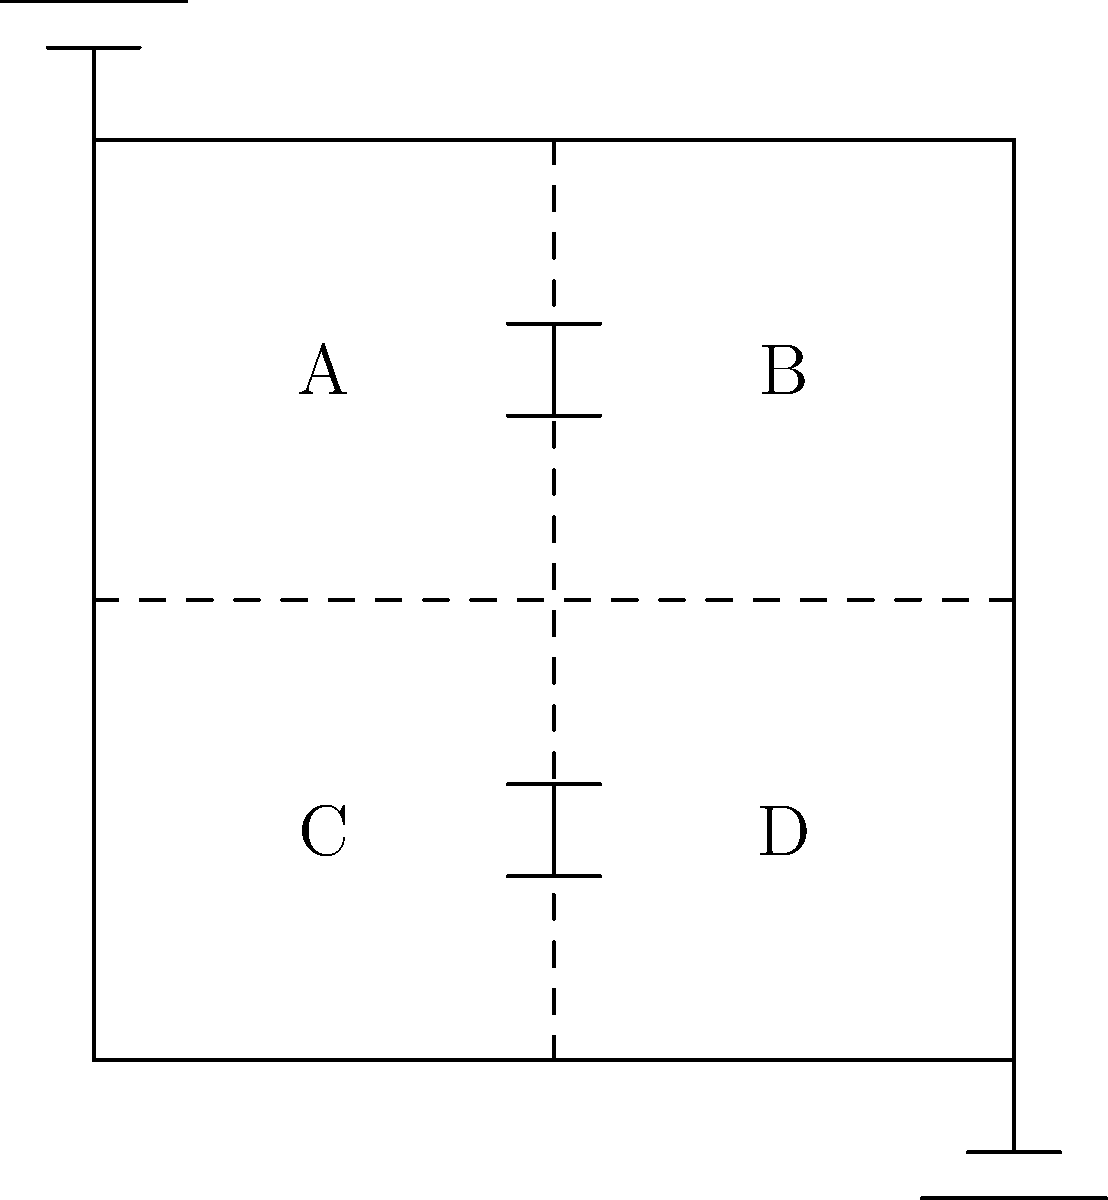In the given circuit diagram, which area(s) would require the highest level of plastic insulation to ensure optimal performance and safety, considering current market trends and regulations in the electrical insulation industry? To determine the optimal placement of plastic insulation in this electrical system, we need to consider several factors:

1. Voltage distribution: In a typical circuit, the highest voltage difference is usually between the power source and ground. This suggests that areas A and B would require more insulation than C and D.

2. Component sensitivity: Capacitors (shown in the middle of the circuit) are often more sensitive to electrical breakdown than resistors. This indicates that the areas around the capacitors might need extra insulation.

3. Current market trends: Recent trends in the plastic insulation market have focused on developing materials with higher dielectric strength and better heat resistance, particularly for high-voltage applications.

4. Regulations: Many new regulations emphasize the importance of insulation in areas with the highest potential for electrical hazards, which typically include points closest to power sources and areas with sensitive components.

5. Cost-effectiveness: While it's important to ensure safety, over-insulating areas with lower risk can increase costs unnecessarily.

Considering these factors:

- Area A is closest to the power source and contains a capacitor, making it a high-priority area for insulation.
- Area B is also close to the power source but only contains a resistor, so it needs good insulation but perhaps not as critical as A.
- Areas C and D are closer to the ground and likely have lower voltage, so they require less insulation.

Given current market trends and regulations emphasizing safety in high-risk areas, the optimal placement for the highest level of plastic insulation would be in Area A, followed closely by Area B.
Answer: Area A 